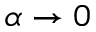Convert formula to latex. <formula><loc_0><loc_0><loc_500><loc_500>\alpha \to 0</formula> 